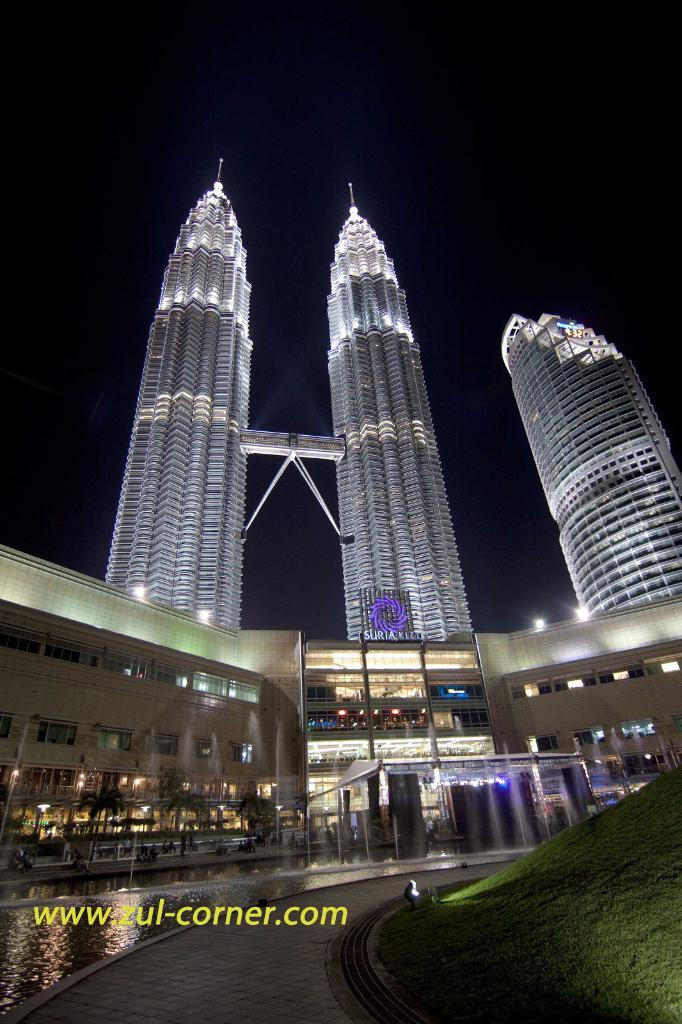What is the main structure in the image? There is a big building in the image. What type of vegetation can be seen in the image? There is grass in the bottom right corner of the image. What is visible in the background of the image? The background of the image is the sky. Can you see a girl flying a kite in the image? There is no girl or kite present in the image. Is there a fire visible in the image? There is no fire present in the image. 